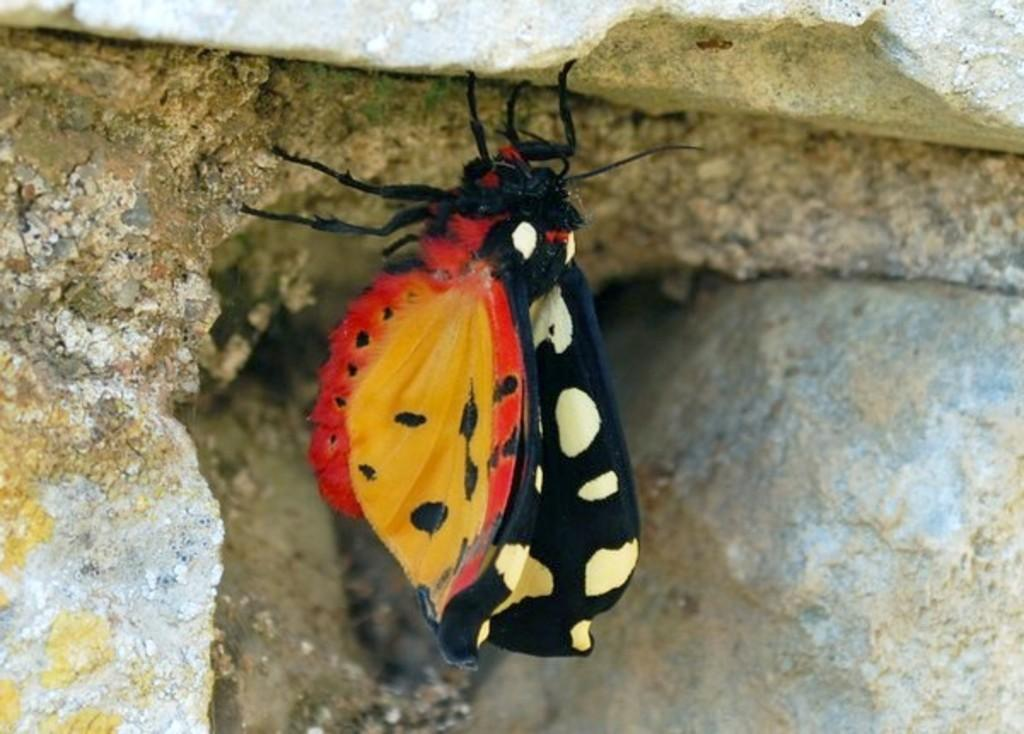What is the main subject of the picture? The main subject of the picture is a butterfly. Can you describe the colors of the butterfly? The butterfly has black, yellow, and red colors. Where is the butterfly located in the picture? The butterfly is on the rocks. What type of letter is the butterfly holding in the picture? There is no letter present in the image, as the butterfly is not holding anything. 